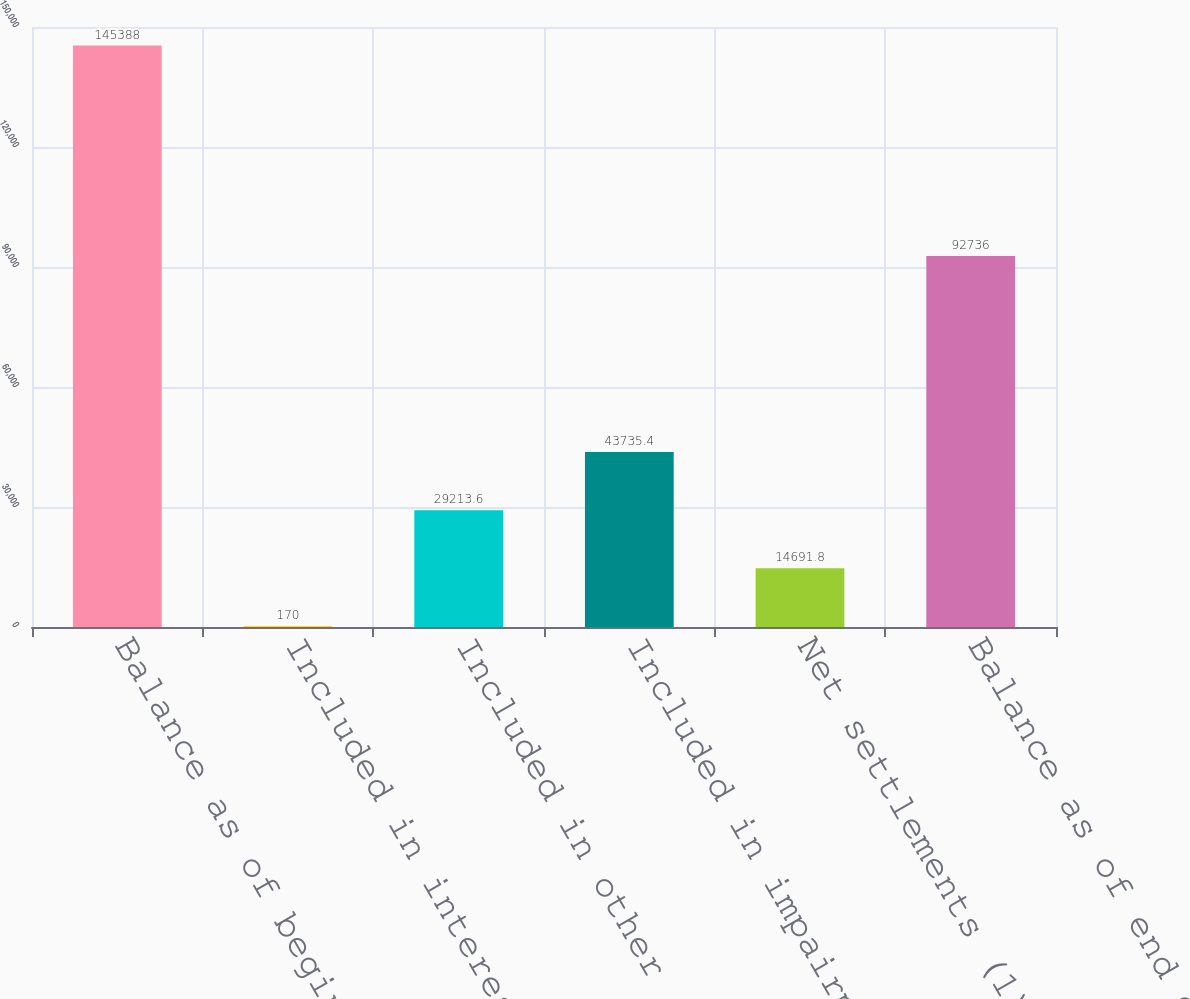Convert chart. <chart><loc_0><loc_0><loc_500><loc_500><bar_chart><fcel>Balance as of beginning of<fcel>Included in interest and other<fcel>Included in other<fcel>Included in impairment loss on<fcel>Net settlements (1)<fcel>Balance as of end of fiscal<nl><fcel>145388<fcel>170<fcel>29213.6<fcel>43735.4<fcel>14691.8<fcel>92736<nl></chart> 